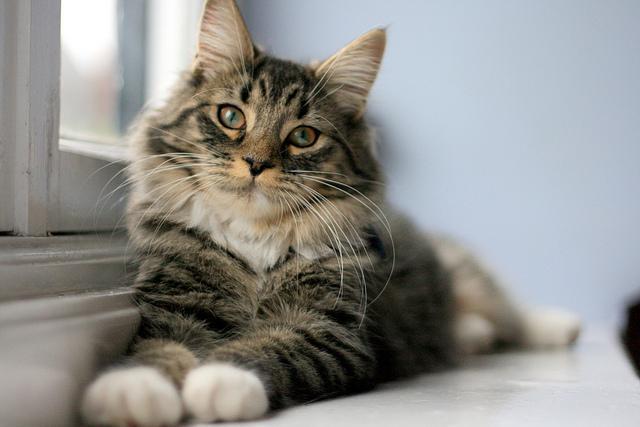How many cats are there?
Give a very brief answer. 1. How many microwaves are in the kitchen?
Give a very brief answer. 0. 